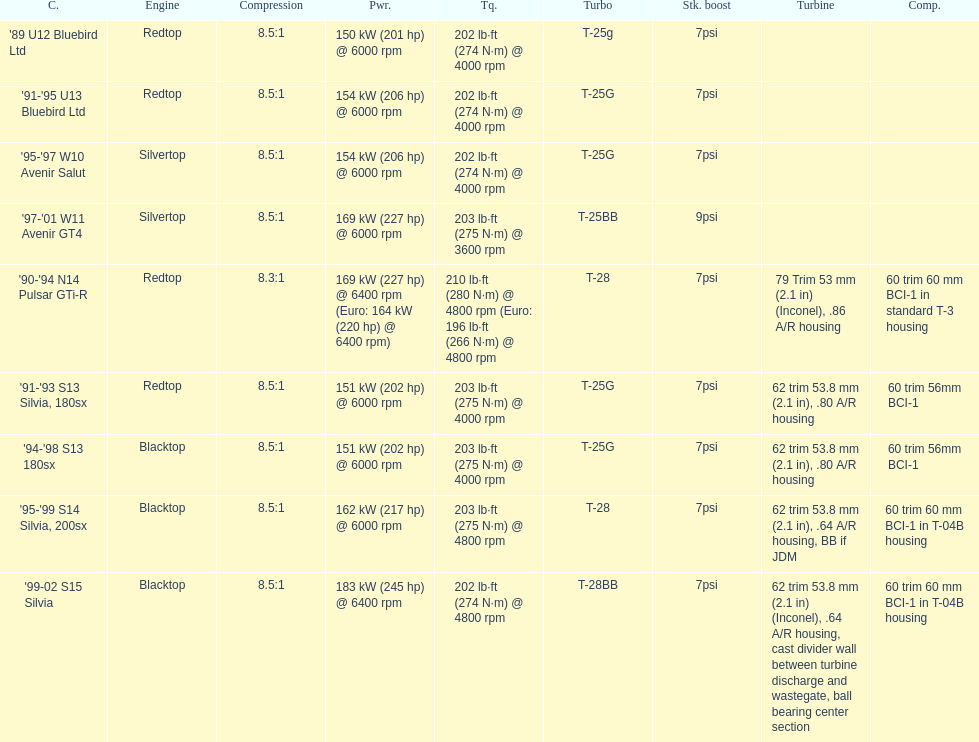Which car has a stock boost of over 7psi? '97-'01 W11 Avenir GT4. 